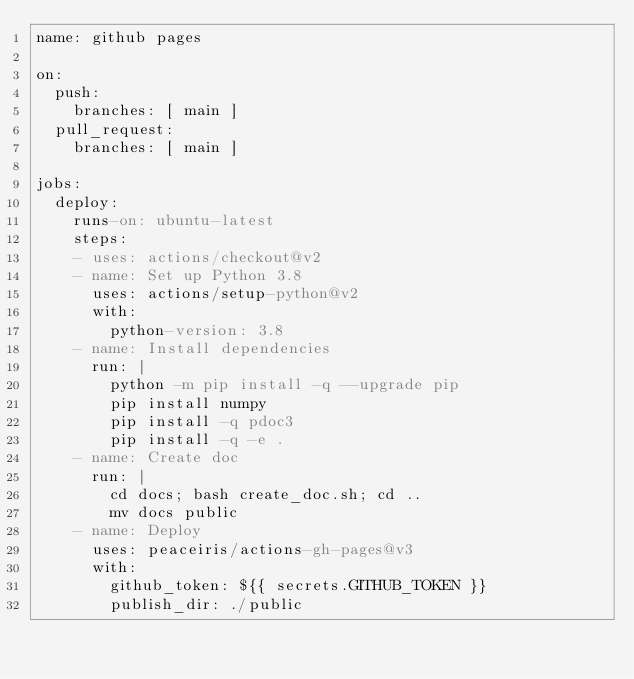<code> <loc_0><loc_0><loc_500><loc_500><_YAML_>name: github pages

on:
  push:
    branches: [ main ]
  pull_request:
    branches: [ main ]

jobs:
  deploy:
    runs-on: ubuntu-latest
    steps:
    - uses: actions/checkout@v2
    - name: Set up Python 3.8
      uses: actions/setup-python@v2
      with:
        python-version: 3.8
    - name: Install dependencies
      run: |
        python -m pip install -q --upgrade pip
        pip install numpy
        pip install -q pdoc3
        pip install -q -e .
    - name: Create doc
      run: |
        cd docs; bash create_doc.sh; cd ..
        mv docs public
    - name: Deploy
      uses: peaceiris/actions-gh-pages@v3
      with:
        github_token: ${{ secrets.GITHUB_TOKEN }}
        publish_dir: ./public
</code> 